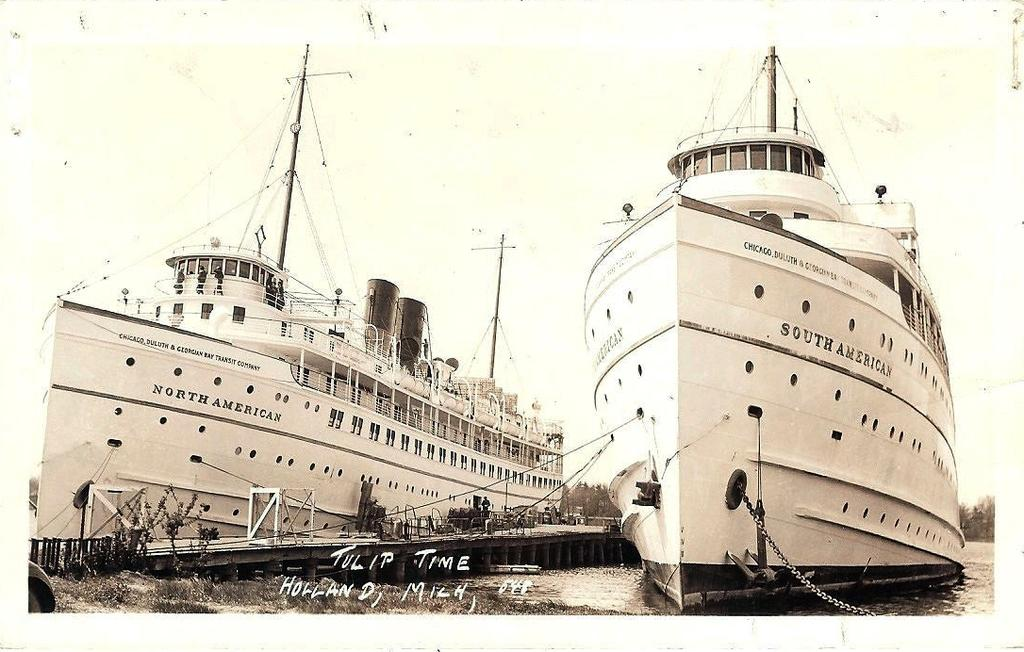<image>
Render a clear and concise summary of the photo. The North American and South  American ship sitting at a dock. 